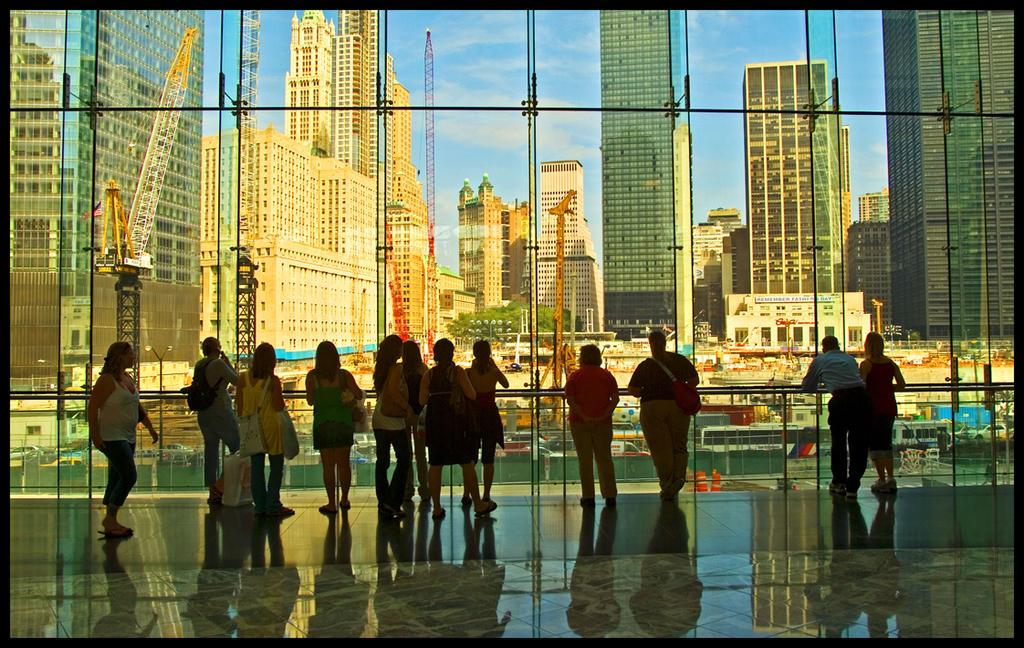What types of people are present in the image? There are men and women in the image. What are the people in the image doing? The people are standing and watching a view. How is the view being observed in the image? The view is seen through a glass. What can be seen on the other side of the view? High-rise buildings are visible on the other side of the view. How many children are present in the image, and what are they feeling? There is no mention of children in the image, so we cannot determine their presence or feelings. 